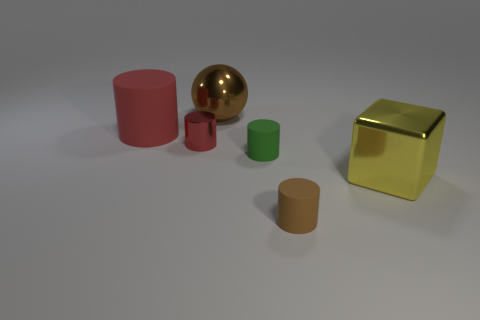What size is the rubber cylinder that is the same color as the shiny cylinder?
Your answer should be compact. Large. There is a cylinder that is the same color as the sphere; what is its material?
Provide a succinct answer. Rubber. What color is the other large thing that is the same shape as the green thing?
Your answer should be very brief. Red. What number of other things are the same color as the large rubber cylinder?
Offer a very short reply. 1. Do the matte object that is on the left side of the small red metallic cylinder and the metal object right of the brown matte cylinder have the same shape?
Offer a terse response. No. How many balls are big yellow things or green things?
Your answer should be very brief. 0. Is the number of brown rubber things to the left of the large matte cylinder less than the number of tiny metallic cylinders?
Your answer should be compact. Yes. Does the red matte object have the same size as the ball?
Provide a short and direct response. Yes. How many things are either tiny cylinders to the left of the ball or yellow metallic objects?
Give a very brief answer. 2. There is a tiny cylinder that is on the left side of the big thing that is behind the large red rubber cylinder; what is it made of?
Offer a very short reply. Metal. 